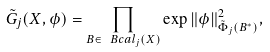<formula> <loc_0><loc_0><loc_500><loc_500>\tilde { G } _ { j } ( X , \phi ) = \prod _ { B \in \ B c a l _ { j } ( X ) } \exp \| \phi \| _ { \tilde { \Phi } _ { j } ( B ^ { * } ) } ^ { 2 } ,</formula> 